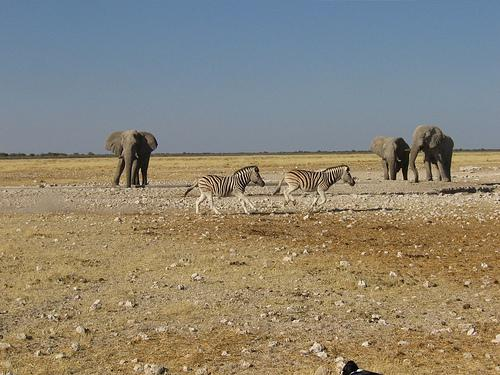Question: what is in the sky?
Choices:
A. A bird.
B. A cloud.
C. The sun.
D. Nothing.
Answer with the letter. Answer: D Question: what is on the horizon?
Choices:
A. A tree.
B. The sun.
C. A mountain.
D. Vegetation.
Answer with the letter. Answer: D Question: why are they in motion?
Choices:
A. Cycling.
B. Jogging.
C. Running.
D. Walking.
Answer with the letter. Answer: C Question: how is the photo?
Choices:
A. Fuzzy.
B. Blurry.
C. Clear.
D. Out of focus.
Answer with the letter. Answer: C Question: what else is in the photo?
Choices:
A. Elephants.
B. Rhinos.
C. Lions.
D. Cheetahs.
Answer with the letter. Answer: A 